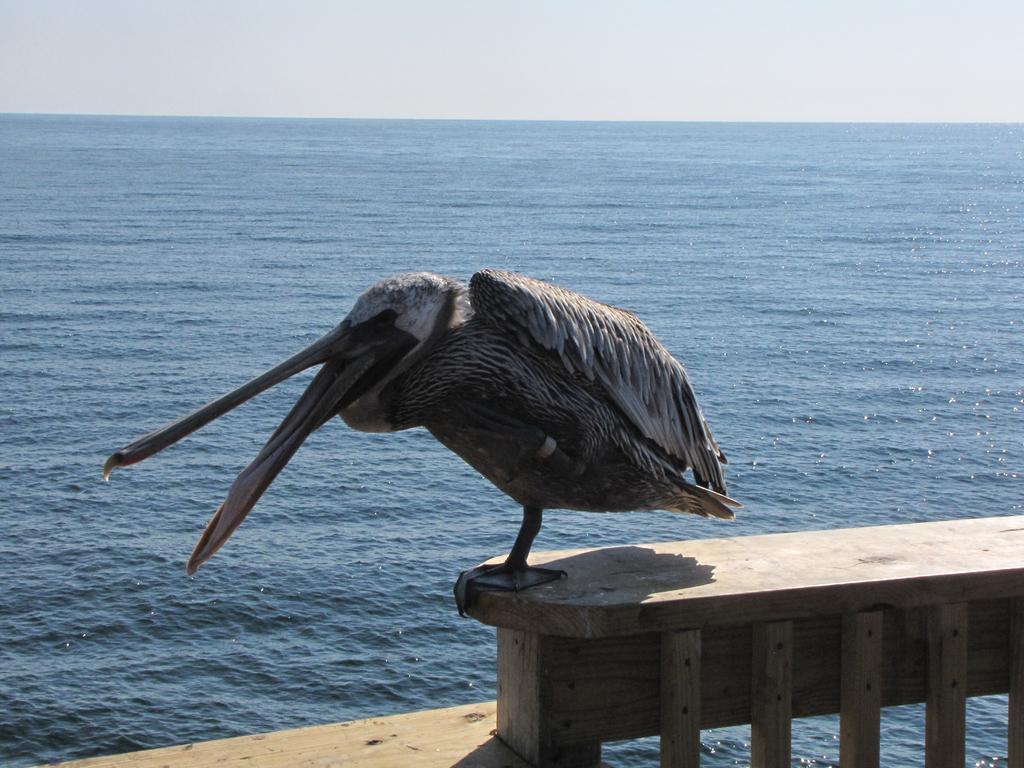Could you give a brief overview of what you see in this image? In the center of the image a bird is standing on the railing. In the background of the image water is present. At the top of the image sky is there. 